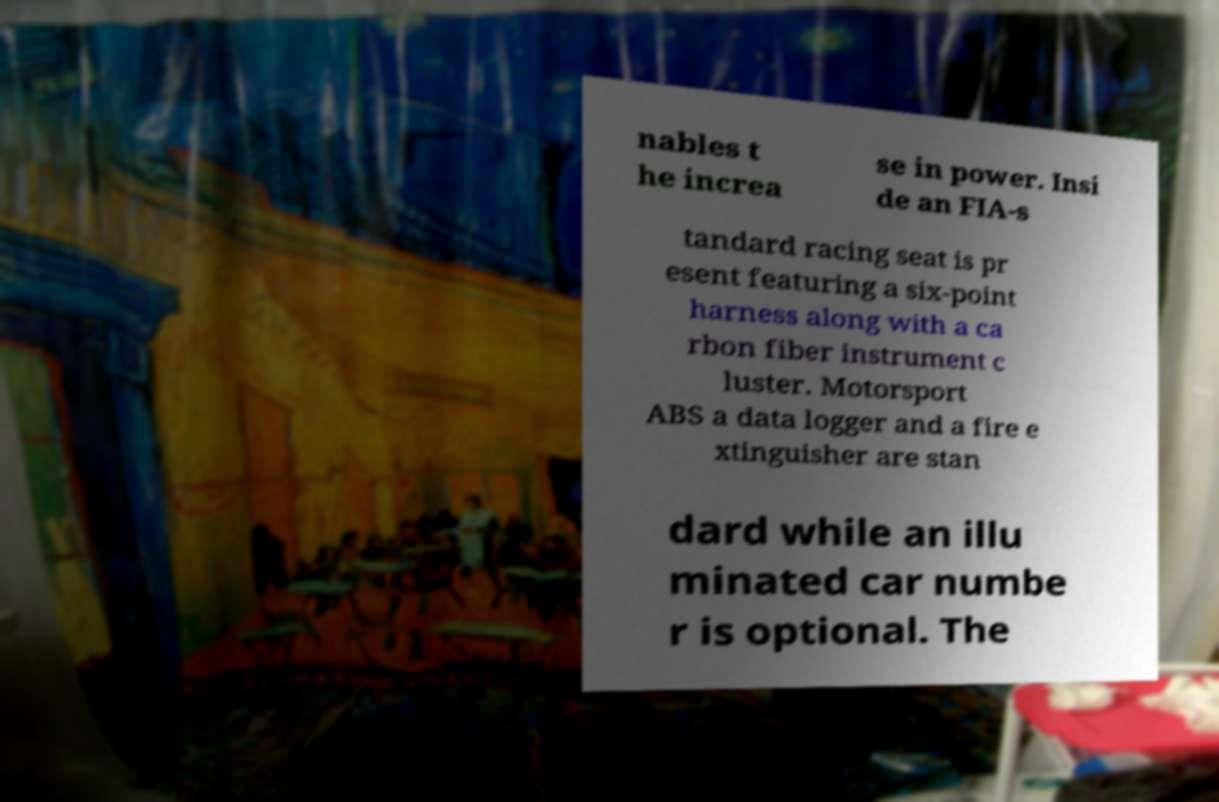Can you read and provide the text displayed in the image?This photo seems to have some interesting text. Can you extract and type it out for me? nables t he increa se in power. Insi de an FIA-s tandard racing seat is pr esent featuring a six-point harness along with a ca rbon fiber instrument c luster. Motorsport ABS a data logger and a fire e xtinguisher are stan dard while an illu minated car numbe r is optional. The 